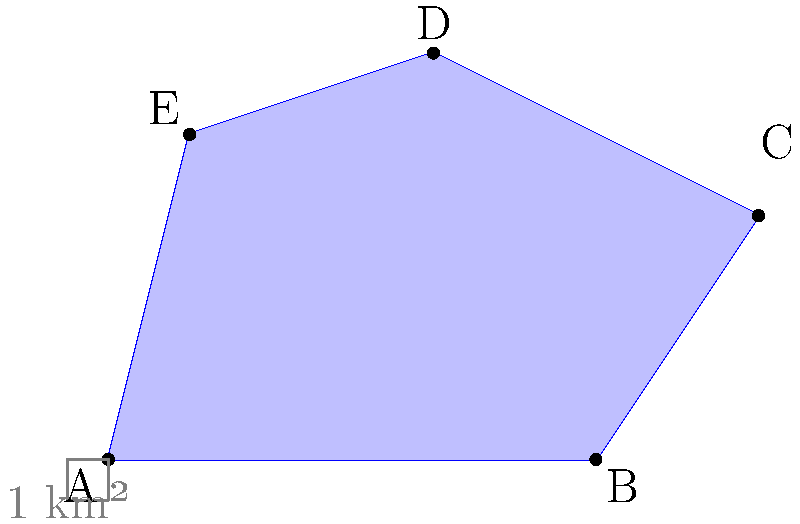Using the aerial imagery of an irregularly shaped land parcel claimed by an indigenous community, calculate its area in square kilometers. The scale provided indicates that each small square represents 1 km². To calculate the area of this irregularly shaped land parcel, we can use the shoelace formula (also known as the surveyor's formula). This method is particularly useful for calculating the area of irregular polygons.

Step 1: Identify the vertices of the polygon.
We have 5 vertices: A(0,0), B(6,0), C(8,3), D(4,5), E(1,4)

Step 2: Apply the shoelace formula:
Area = $\frac{1}{2}|((x_1y_2 + x_2y_3 + ... + x_ny_1) - (y_1x_2 + y_2x_3 + ... + y_nx_1))|$

Step 3: Substitute the values:
Area = $\frac{1}{2}|((0 \cdot 0 + 6 \cdot 3 + 8 \cdot 5 + 4 \cdot 4 + 1 \cdot 0) - (0 \cdot 6 + 0 \cdot 8 + 3 \cdot 4 + 5 \cdot 1 + 4 \cdot 0))|$

Step 4: Calculate:
Area = $\frac{1}{2}|((0 + 18 + 40 + 16 + 0) - (0 + 0 + 12 + 5 + 0))|$
Area = $\frac{1}{2}|(74 - 17)|$
Area = $\frac{1}{2} \cdot 57$
Area = 28.5 km²

Therefore, the area of the irregularly shaped land parcel is 28.5 square kilometers.
Answer: 28.5 km² 